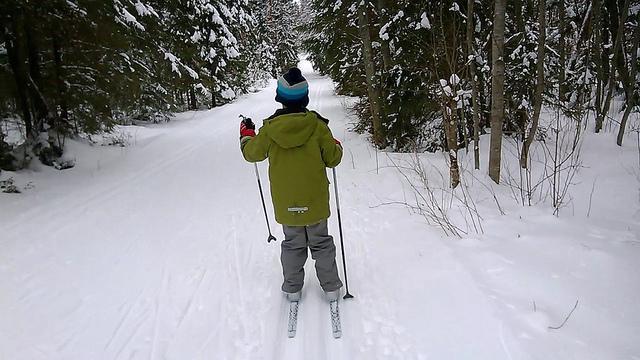How many orange boats are there?
Give a very brief answer. 0. 